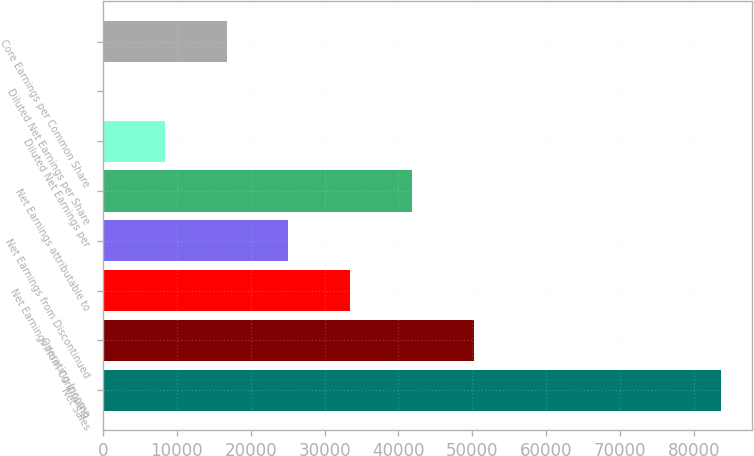<chart> <loc_0><loc_0><loc_500><loc_500><bar_chart><fcel>Net Sales<fcel>Operating Income<fcel>Net Earnings from Continuing<fcel>Net Earnings from Discontinued<fcel>Net Earnings attributable to<fcel>Diluted Net Earnings per<fcel>Diluted Net Earnings per Share<fcel>Core Earnings per Common Share<nl><fcel>83680<fcel>50209.3<fcel>33473.9<fcel>25106.2<fcel>41841.6<fcel>8370.81<fcel>3.12<fcel>16738.5<nl></chart> 